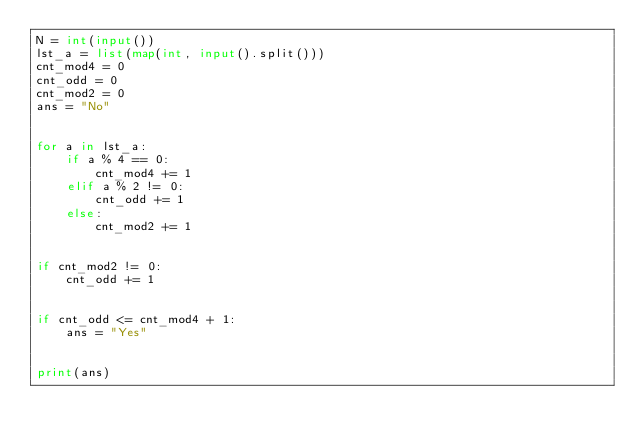Convert code to text. <code><loc_0><loc_0><loc_500><loc_500><_Python_>N = int(input())
lst_a = list(map(int, input().split()))
cnt_mod4 = 0
cnt_odd = 0
cnt_mod2 = 0
ans = "No"


for a in lst_a:
    if a % 4 == 0:
        cnt_mod4 += 1
    elif a % 2 != 0:
        cnt_odd += 1
    else:
        cnt_mod2 += 1


if cnt_mod2 != 0:
    cnt_odd += 1


if cnt_odd <= cnt_mod4 + 1:
    ans = "Yes"


print(ans)</code> 